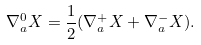<formula> <loc_0><loc_0><loc_500><loc_500>\nabla _ { a } ^ { 0 } X = \frac { 1 } { 2 } ( \nabla _ { a } ^ { + } X + \nabla _ { a } ^ { - } X ) .</formula> 